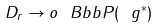Convert formula to latex. <formula><loc_0><loc_0><loc_500><loc_500>D _ { r } \to o \ B b b P ( \ g ^ { * } )</formula> 